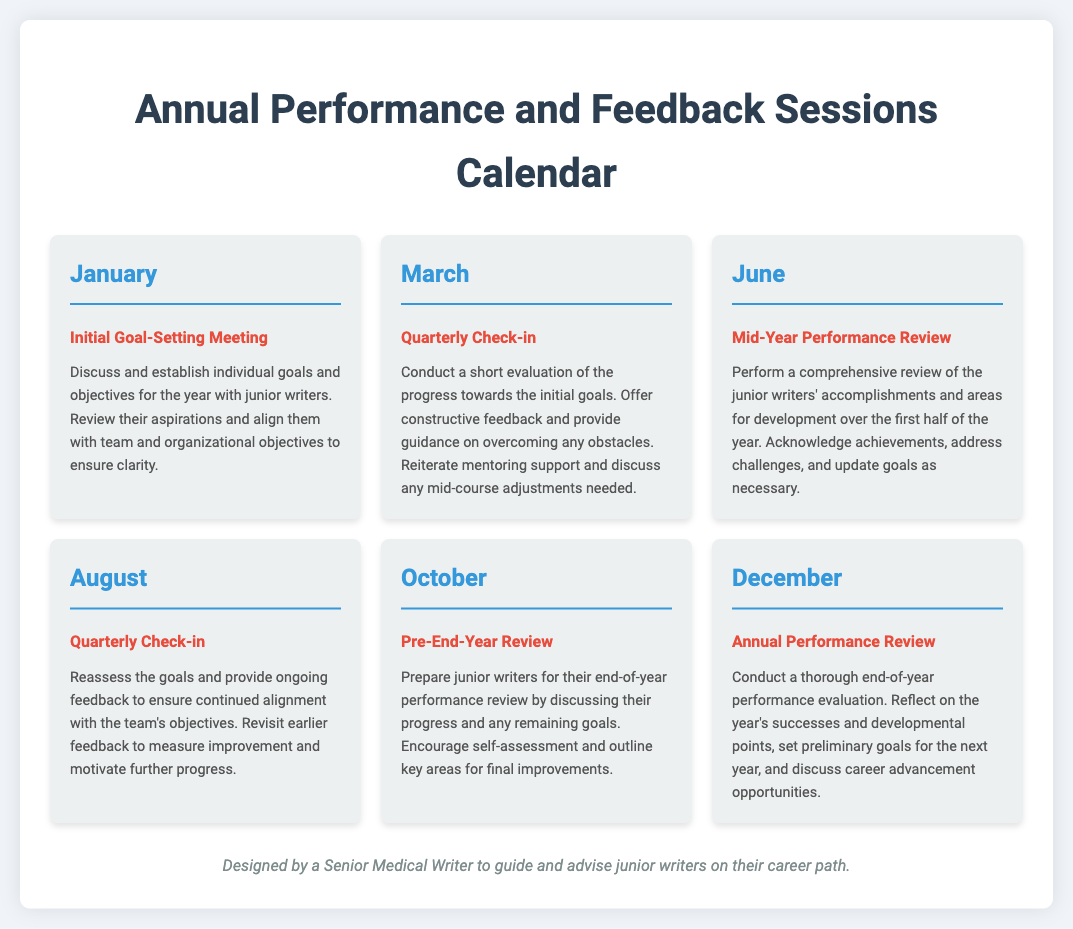What is the first activity listed in the calendar? The first activity listed in the calendar is "Initial Goal-Setting Meeting" in January.
Answer: Initial Goal-Setting Meeting How many quarterly check-ins are scheduled during the year? There are two quarterly check-ins scheduled in March and August.
Answer: 2 Which month is the Mid-Year Performance Review scheduled for? The Mid-Year Performance Review is scheduled for June.
Answer: June What is the last activity in the calendar? The last activity in the calendar is "Annual Performance Review" in December.
Answer: Annual Performance Review In which month do junior writers prepare for their end-of-year performance review? Junior writers prepare for their end-of-year performance review in October.
Answer: October What is the purpose of the August quarterly check-in? The purpose of the August quarterly check-in is to reassess goals and provide ongoing feedback.
Answer: Reassess goals and provide ongoing feedback How many months are included in the annual performance calendar? The calendar includes twelve months, each with specified activities related to performance and feedback.
Answer: 12 What type of meetings are scheduled for October? The type of meetings scheduled for October is "Pre-End-Year Review."
Answer: Pre-End-Year Review What is discussed during the Annual Performance Review? During the Annual Performance Review, the year's successes and developmental points are discussed.
Answer: Year's successes and developmental points 